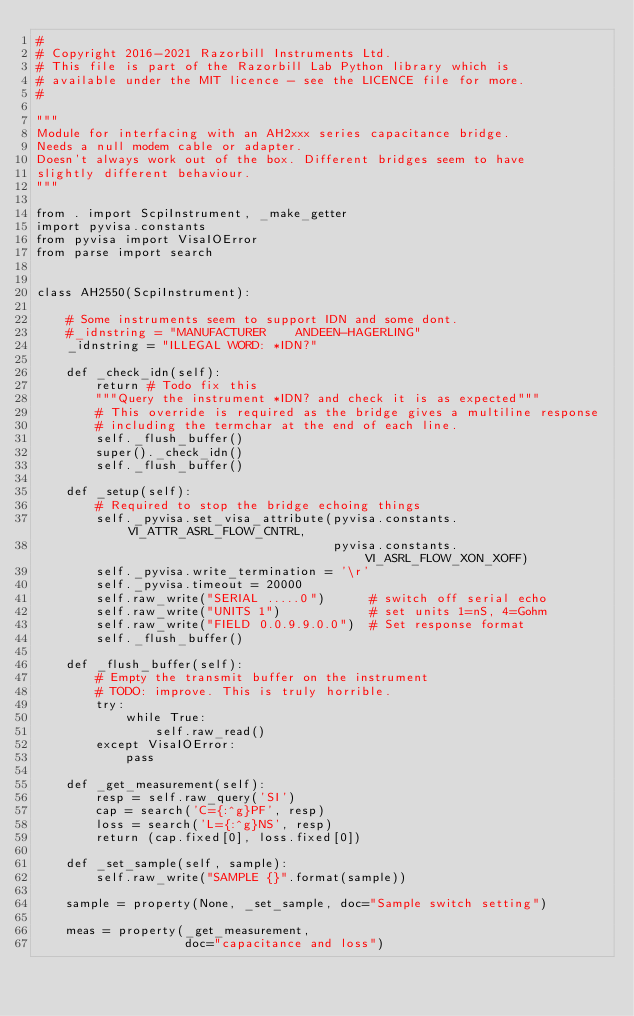Convert code to text. <code><loc_0><loc_0><loc_500><loc_500><_Python_>#
# Copyright 2016-2021 Razorbill Instruments Ltd.
# This file is part of the Razorbill Lab Python library which is
# available under the MIT licence - see the LICENCE file for more.
#

"""
Module for interfacing with an AH2xxx series capacitance bridge.
Needs a null modem cable or adapter.
Doesn't always work out of the box. Different bridges seem to have 
slightly different behaviour.
"""

from . import ScpiInstrument, _make_getter
import pyvisa.constants
from pyvisa import VisaIOError
from parse import search


class AH2550(ScpiInstrument):

    # Some instruments seem to support IDN and some dont.
    #_idnstring = "MANUFACTURER    ANDEEN-HAGERLING"
    _idnstring = "ILLEGAL WORD: *IDN?"

    def _check_idn(self):
        return # Todo fix this
        """Query the instrument *IDN? and check it is as expected"""
        # This override is required as the bridge gives a multiline response
        # including the termchar at the end of each line.
        self._flush_buffer()
        super()._check_idn()
        self._flush_buffer()

    def _setup(self):
        # Required to stop the bridge echoing things
        self._pyvisa.set_visa_attribute(pyvisa.constants.VI_ATTR_ASRL_FLOW_CNTRL,
                                        pyvisa.constants.VI_ASRL_FLOW_XON_XOFF)
        self._pyvisa.write_termination = '\r'
        self._pyvisa.timeout = 20000
        self.raw_write("SERIAL .....0")      # switch off serial echo
        self.raw_write("UNITS 1")            # set units 1=nS, 4=Gohm
        self.raw_write("FIELD 0.0.9.9.0.0")  # Set response format
        self._flush_buffer()

    def _flush_buffer(self):
        # Empty the transmit buffer on the instrument
        # TODO: improve. This is truly horrible.
        try:
            while True:
                self.raw_read()
        except VisaIOError:
            pass

    def _get_measurement(self):
        resp = self.raw_query('SI')
        cap = search('C={:^g}PF', resp)
        loss = search('L={:^g}NS', resp)
        return (cap.fixed[0], loss.fixed[0])

    def _set_sample(self, sample):
        self.raw_write("SAMPLE {}".format(sample))

    sample = property(None, _set_sample, doc="Sample switch setting")

    meas = property(_get_measurement,
                    doc="capacitance and loss")
</code> 